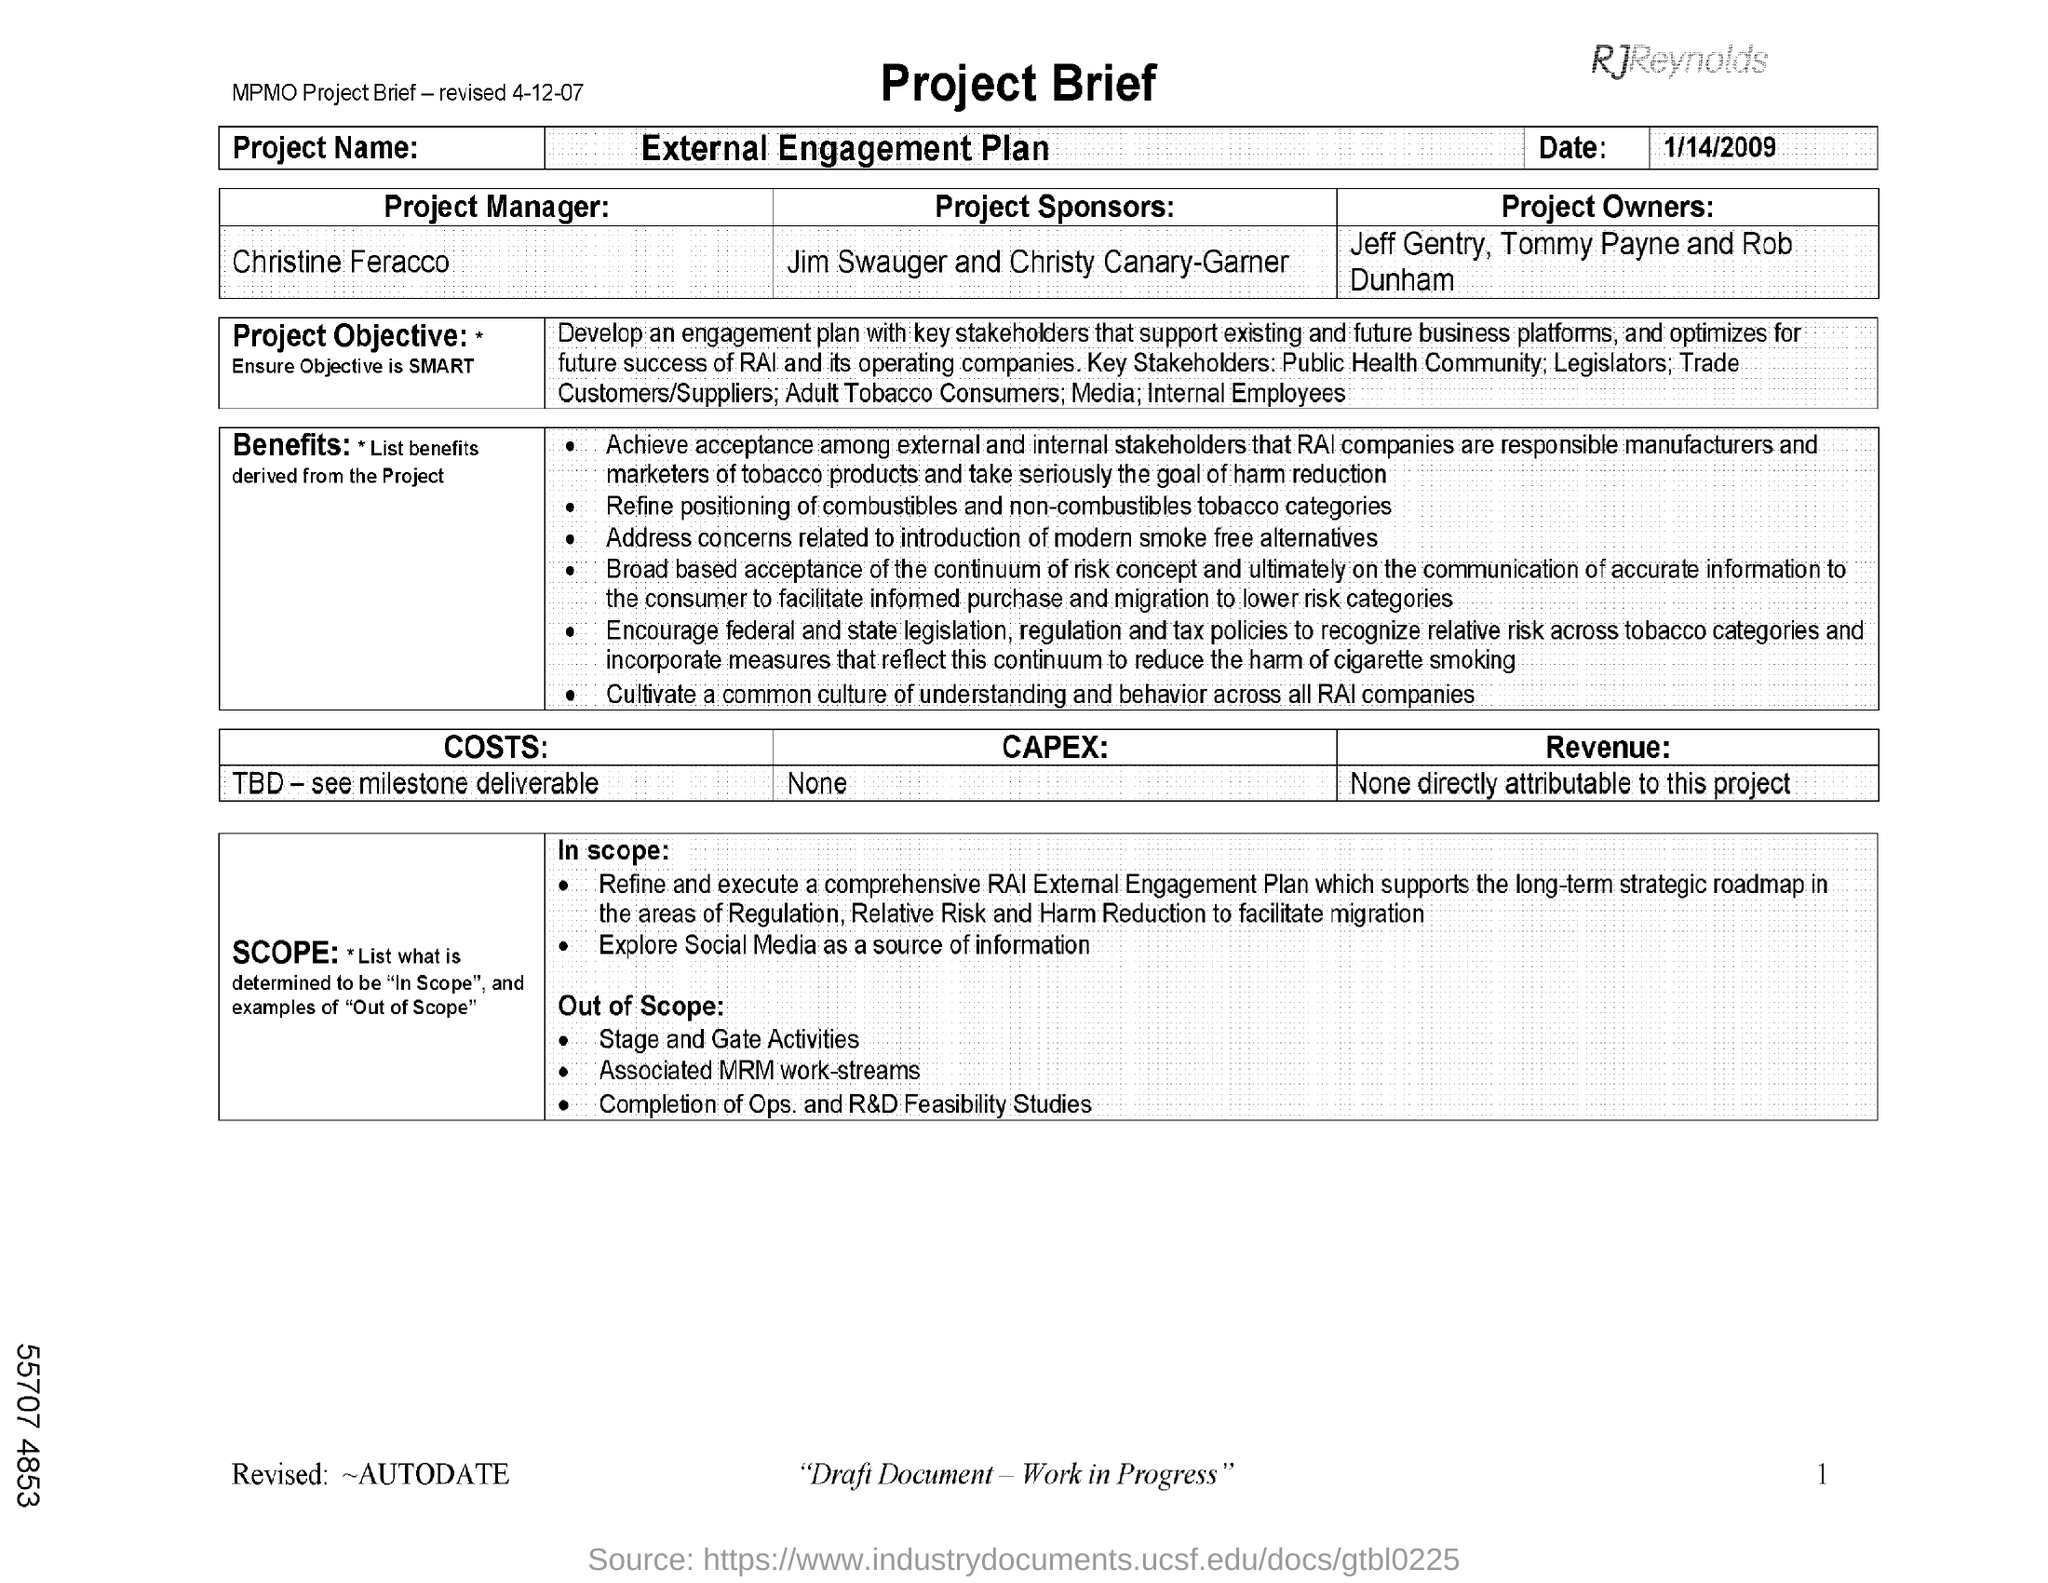Mention a couple of crucial points in this snapshot. Christine Feracco is the Project Manager for the project. The date mentioned in the document is January 14, 2009. The project name is External Engagement Plan. 